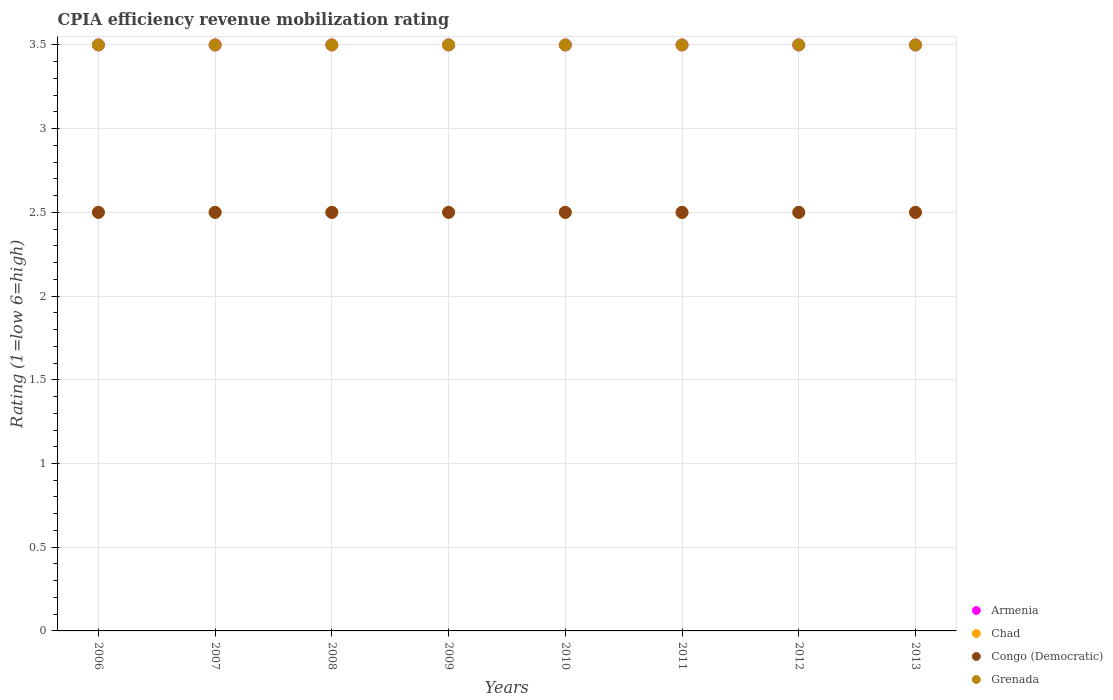Across all years, what is the maximum CPIA rating in Congo (Democratic)?
Your answer should be compact. 2.5. What is the total CPIA rating in Armenia in the graph?
Make the answer very short. 28. What is the difference between the CPIA rating in Chad in 2009 and that in 2013?
Your answer should be compact. 0. What is the average CPIA rating in Congo (Democratic) per year?
Your response must be concise. 2.5. In the year 2010, what is the difference between the CPIA rating in Armenia and CPIA rating in Chad?
Provide a succinct answer. 1. Is the CPIA rating in Chad in 2011 less than that in 2012?
Give a very brief answer. No. What is the difference between the highest and the lowest CPIA rating in Congo (Democratic)?
Make the answer very short. 0. Is the sum of the CPIA rating in Chad in 2010 and 2013 greater than the maximum CPIA rating in Armenia across all years?
Keep it short and to the point. Yes. Is the CPIA rating in Armenia strictly greater than the CPIA rating in Grenada over the years?
Provide a short and direct response. No. Is the CPIA rating in Chad strictly less than the CPIA rating in Congo (Democratic) over the years?
Your answer should be very brief. No. How many dotlines are there?
Provide a short and direct response. 4. How many years are there in the graph?
Give a very brief answer. 8. Are the values on the major ticks of Y-axis written in scientific E-notation?
Provide a succinct answer. No. Does the graph contain grids?
Your answer should be compact. Yes. How many legend labels are there?
Your answer should be very brief. 4. How are the legend labels stacked?
Your answer should be compact. Vertical. What is the title of the graph?
Offer a very short reply. CPIA efficiency revenue mobilization rating. What is the label or title of the Y-axis?
Your answer should be very brief. Rating (1=low 6=high). What is the Rating (1=low 6=high) of Armenia in 2006?
Your answer should be very brief. 3.5. What is the Rating (1=low 6=high) in Congo (Democratic) in 2006?
Your answer should be compact. 2.5. What is the Rating (1=low 6=high) in Grenada in 2006?
Keep it short and to the point. 3.5. What is the Rating (1=low 6=high) of Armenia in 2007?
Make the answer very short. 3.5. What is the Rating (1=low 6=high) in Chad in 2007?
Give a very brief answer. 2.5. What is the Rating (1=low 6=high) of Congo (Democratic) in 2007?
Give a very brief answer. 2.5. What is the Rating (1=low 6=high) in Grenada in 2007?
Your response must be concise. 3.5. What is the Rating (1=low 6=high) of Armenia in 2008?
Provide a succinct answer. 3.5. What is the Rating (1=low 6=high) of Chad in 2008?
Your answer should be compact. 2.5. What is the Rating (1=low 6=high) of Grenada in 2008?
Give a very brief answer. 3.5. What is the Rating (1=low 6=high) in Chad in 2009?
Your answer should be very brief. 2.5. What is the Rating (1=low 6=high) in Grenada in 2009?
Keep it short and to the point. 3.5. What is the Rating (1=low 6=high) in Armenia in 2010?
Offer a terse response. 3.5. What is the Rating (1=low 6=high) of Chad in 2010?
Offer a terse response. 2.5. What is the Rating (1=low 6=high) of Congo (Democratic) in 2010?
Your response must be concise. 2.5. What is the Rating (1=low 6=high) in Grenada in 2010?
Provide a succinct answer. 3.5. What is the Rating (1=low 6=high) in Armenia in 2011?
Ensure brevity in your answer.  3.5. What is the Rating (1=low 6=high) in Chad in 2011?
Ensure brevity in your answer.  2.5. What is the Rating (1=low 6=high) in Congo (Democratic) in 2011?
Your response must be concise. 2.5. What is the Rating (1=low 6=high) in Armenia in 2012?
Your answer should be very brief. 3.5. What is the Rating (1=low 6=high) in Congo (Democratic) in 2012?
Your answer should be very brief. 2.5. What is the Rating (1=low 6=high) of Grenada in 2012?
Make the answer very short. 3.5. What is the Rating (1=low 6=high) of Grenada in 2013?
Your answer should be compact. 3.5. Across all years, what is the maximum Rating (1=low 6=high) in Congo (Democratic)?
Give a very brief answer. 2.5. Across all years, what is the minimum Rating (1=low 6=high) in Congo (Democratic)?
Give a very brief answer. 2.5. Across all years, what is the minimum Rating (1=low 6=high) of Grenada?
Give a very brief answer. 3.5. What is the total Rating (1=low 6=high) of Chad in the graph?
Your answer should be very brief. 20. What is the total Rating (1=low 6=high) of Congo (Democratic) in the graph?
Ensure brevity in your answer.  20. What is the difference between the Rating (1=low 6=high) in Armenia in 2006 and that in 2007?
Give a very brief answer. 0. What is the difference between the Rating (1=low 6=high) in Chad in 2006 and that in 2007?
Offer a terse response. 0. What is the difference between the Rating (1=low 6=high) of Grenada in 2006 and that in 2007?
Ensure brevity in your answer.  0. What is the difference between the Rating (1=low 6=high) of Armenia in 2006 and that in 2008?
Offer a very short reply. 0. What is the difference between the Rating (1=low 6=high) of Congo (Democratic) in 2006 and that in 2008?
Make the answer very short. 0. What is the difference between the Rating (1=low 6=high) of Grenada in 2006 and that in 2008?
Offer a very short reply. 0. What is the difference between the Rating (1=low 6=high) in Chad in 2006 and that in 2009?
Offer a very short reply. 0. What is the difference between the Rating (1=low 6=high) in Chad in 2006 and that in 2010?
Your answer should be compact. 0. What is the difference between the Rating (1=low 6=high) in Congo (Democratic) in 2006 and that in 2010?
Your answer should be very brief. 0. What is the difference between the Rating (1=low 6=high) in Armenia in 2006 and that in 2011?
Provide a short and direct response. 0. What is the difference between the Rating (1=low 6=high) in Armenia in 2006 and that in 2012?
Your answer should be very brief. 0. What is the difference between the Rating (1=low 6=high) in Chad in 2006 and that in 2012?
Your answer should be compact. 0. What is the difference between the Rating (1=low 6=high) of Congo (Democratic) in 2006 and that in 2012?
Provide a short and direct response. 0. What is the difference between the Rating (1=low 6=high) in Grenada in 2006 and that in 2012?
Provide a succinct answer. 0. What is the difference between the Rating (1=low 6=high) in Armenia in 2006 and that in 2013?
Your response must be concise. 0. What is the difference between the Rating (1=low 6=high) in Chad in 2006 and that in 2013?
Keep it short and to the point. 0. What is the difference between the Rating (1=low 6=high) in Congo (Democratic) in 2006 and that in 2013?
Provide a short and direct response. 0. What is the difference between the Rating (1=low 6=high) in Armenia in 2007 and that in 2008?
Your response must be concise. 0. What is the difference between the Rating (1=low 6=high) of Chad in 2007 and that in 2008?
Offer a very short reply. 0. What is the difference between the Rating (1=low 6=high) of Grenada in 2007 and that in 2008?
Keep it short and to the point. 0. What is the difference between the Rating (1=low 6=high) of Armenia in 2007 and that in 2009?
Your answer should be compact. 0. What is the difference between the Rating (1=low 6=high) in Chad in 2007 and that in 2009?
Make the answer very short. 0. What is the difference between the Rating (1=low 6=high) in Congo (Democratic) in 2007 and that in 2009?
Offer a very short reply. 0. What is the difference between the Rating (1=low 6=high) of Grenada in 2007 and that in 2009?
Your response must be concise. 0. What is the difference between the Rating (1=low 6=high) of Chad in 2007 and that in 2010?
Ensure brevity in your answer.  0. What is the difference between the Rating (1=low 6=high) in Chad in 2007 and that in 2011?
Your answer should be compact. 0. What is the difference between the Rating (1=low 6=high) of Grenada in 2007 and that in 2011?
Your response must be concise. 0. What is the difference between the Rating (1=low 6=high) of Armenia in 2007 and that in 2012?
Your answer should be very brief. 0. What is the difference between the Rating (1=low 6=high) in Congo (Democratic) in 2007 and that in 2012?
Keep it short and to the point. 0. What is the difference between the Rating (1=low 6=high) of Grenada in 2007 and that in 2012?
Make the answer very short. 0. What is the difference between the Rating (1=low 6=high) of Armenia in 2007 and that in 2013?
Provide a short and direct response. 0. What is the difference between the Rating (1=low 6=high) of Congo (Democratic) in 2007 and that in 2013?
Offer a terse response. 0. What is the difference between the Rating (1=low 6=high) of Grenada in 2007 and that in 2013?
Offer a terse response. 0. What is the difference between the Rating (1=low 6=high) in Armenia in 2008 and that in 2010?
Your response must be concise. 0. What is the difference between the Rating (1=low 6=high) in Congo (Democratic) in 2008 and that in 2010?
Your answer should be very brief. 0. What is the difference between the Rating (1=low 6=high) of Grenada in 2008 and that in 2010?
Your answer should be compact. 0. What is the difference between the Rating (1=low 6=high) of Armenia in 2008 and that in 2011?
Keep it short and to the point. 0. What is the difference between the Rating (1=low 6=high) of Grenada in 2008 and that in 2011?
Your response must be concise. 0. What is the difference between the Rating (1=low 6=high) in Congo (Democratic) in 2008 and that in 2012?
Offer a terse response. 0. What is the difference between the Rating (1=low 6=high) of Armenia in 2008 and that in 2013?
Your response must be concise. 0. What is the difference between the Rating (1=low 6=high) in Chad in 2008 and that in 2013?
Ensure brevity in your answer.  0. What is the difference between the Rating (1=low 6=high) of Grenada in 2008 and that in 2013?
Your answer should be compact. 0. What is the difference between the Rating (1=low 6=high) of Grenada in 2009 and that in 2010?
Your answer should be compact. 0. What is the difference between the Rating (1=low 6=high) in Armenia in 2009 and that in 2011?
Make the answer very short. 0. What is the difference between the Rating (1=low 6=high) of Congo (Democratic) in 2009 and that in 2011?
Ensure brevity in your answer.  0. What is the difference between the Rating (1=low 6=high) of Chad in 2009 and that in 2012?
Provide a succinct answer. 0. What is the difference between the Rating (1=low 6=high) of Grenada in 2009 and that in 2012?
Offer a terse response. 0. What is the difference between the Rating (1=low 6=high) of Chad in 2009 and that in 2013?
Keep it short and to the point. 0. What is the difference between the Rating (1=low 6=high) in Congo (Democratic) in 2009 and that in 2013?
Give a very brief answer. 0. What is the difference between the Rating (1=low 6=high) of Armenia in 2010 and that in 2011?
Give a very brief answer. 0. What is the difference between the Rating (1=low 6=high) of Armenia in 2010 and that in 2012?
Provide a short and direct response. 0. What is the difference between the Rating (1=low 6=high) of Congo (Democratic) in 2010 and that in 2012?
Give a very brief answer. 0. What is the difference between the Rating (1=low 6=high) of Grenada in 2010 and that in 2012?
Provide a short and direct response. 0. What is the difference between the Rating (1=low 6=high) in Armenia in 2010 and that in 2013?
Provide a succinct answer. 0. What is the difference between the Rating (1=low 6=high) of Chad in 2010 and that in 2013?
Offer a terse response. 0. What is the difference between the Rating (1=low 6=high) of Congo (Democratic) in 2011 and that in 2012?
Provide a short and direct response. 0. What is the difference between the Rating (1=low 6=high) in Armenia in 2011 and that in 2013?
Offer a very short reply. 0. What is the difference between the Rating (1=low 6=high) of Grenada in 2011 and that in 2013?
Your answer should be compact. 0. What is the difference between the Rating (1=low 6=high) of Chad in 2012 and that in 2013?
Make the answer very short. 0. What is the difference between the Rating (1=low 6=high) in Grenada in 2012 and that in 2013?
Provide a short and direct response. 0. What is the difference between the Rating (1=low 6=high) in Armenia in 2006 and the Rating (1=low 6=high) in Congo (Democratic) in 2007?
Give a very brief answer. 1. What is the difference between the Rating (1=low 6=high) in Armenia in 2006 and the Rating (1=low 6=high) in Grenada in 2007?
Your response must be concise. 0. What is the difference between the Rating (1=low 6=high) in Chad in 2006 and the Rating (1=low 6=high) in Congo (Democratic) in 2007?
Offer a terse response. 0. What is the difference between the Rating (1=low 6=high) of Chad in 2006 and the Rating (1=low 6=high) of Grenada in 2007?
Your answer should be very brief. -1. What is the difference between the Rating (1=low 6=high) of Armenia in 2006 and the Rating (1=low 6=high) of Chad in 2008?
Keep it short and to the point. 1. What is the difference between the Rating (1=low 6=high) in Armenia in 2006 and the Rating (1=low 6=high) in Congo (Democratic) in 2008?
Ensure brevity in your answer.  1. What is the difference between the Rating (1=low 6=high) of Chad in 2006 and the Rating (1=low 6=high) of Congo (Democratic) in 2008?
Provide a succinct answer. 0. What is the difference between the Rating (1=low 6=high) in Congo (Democratic) in 2006 and the Rating (1=low 6=high) in Grenada in 2008?
Make the answer very short. -1. What is the difference between the Rating (1=low 6=high) of Armenia in 2006 and the Rating (1=low 6=high) of Grenada in 2009?
Your response must be concise. 0. What is the difference between the Rating (1=low 6=high) in Chad in 2006 and the Rating (1=low 6=high) in Congo (Democratic) in 2009?
Provide a succinct answer. 0. What is the difference between the Rating (1=low 6=high) of Chad in 2006 and the Rating (1=low 6=high) of Grenada in 2009?
Ensure brevity in your answer.  -1. What is the difference between the Rating (1=low 6=high) in Congo (Democratic) in 2006 and the Rating (1=low 6=high) in Grenada in 2009?
Keep it short and to the point. -1. What is the difference between the Rating (1=low 6=high) of Armenia in 2006 and the Rating (1=low 6=high) of Chad in 2010?
Your answer should be compact. 1. What is the difference between the Rating (1=low 6=high) of Armenia in 2006 and the Rating (1=low 6=high) of Grenada in 2010?
Your answer should be compact. 0. What is the difference between the Rating (1=low 6=high) in Chad in 2006 and the Rating (1=low 6=high) in Grenada in 2010?
Your response must be concise. -1. What is the difference between the Rating (1=low 6=high) of Congo (Democratic) in 2006 and the Rating (1=low 6=high) of Grenada in 2010?
Your response must be concise. -1. What is the difference between the Rating (1=low 6=high) of Armenia in 2006 and the Rating (1=low 6=high) of Grenada in 2011?
Your answer should be compact. 0. What is the difference between the Rating (1=low 6=high) of Armenia in 2006 and the Rating (1=low 6=high) of Chad in 2012?
Keep it short and to the point. 1. What is the difference between the Rating (1=low 6=high) in Armenia in 2006 and the Rating (1=low 6=high) in Congo (Democratic) in 2012?
Provide a succinct answer. 1. What is the difference between the Rating (1=low 6=high) of Chad in 2006 and the Rating (1=low 6=high) of Congo (Democratic) in 2012?
Keep it short and to the point. 0. What is the difference between the Rating (1=low 6=high) of Congo (Democratic) in 2006 and the Rating (1=low 6=high) of Grenada in 2012?
Provide a short and direct response. -1. What is the difference between the Rating (1=low 6=high) in Armenia in 2006 and the Rating (1=low 6=high) in Chad in 2013?
Make the answer very short. 1. What is the difference between the Rating (1=low 6=high) of Chad in 2006 and the Rating (1=low 6=high) of Congo (Democratic) in 2013?
Keep it short and to the point. 0. What is the difference between the Rating (1=low 6=high) of Chad in 2006 and the Rating (1=low 6=high) of Grenada in 2013?
Provide a succinct answer. -1. What is the difference between the Rating (1=low 6=high) in Congo (Democratic) in 2006 and the Rating (1=low 6=high) in Grenada in 2013?
Your answer should be compact. -1. What is the difference between the Rating (1=low 6=high) of Armenia in 2007 and the Rating (1=low 6=high) of Chad in 2008?
Offer a very short reply. 1. What is the difference between the Rating (1=low 6=high) of Armenia in 2007 and the Rating (1=low 6=high) of Grenada in 2008?
Your response must be concise. 0. What is the difference between the Rating (1=low 6=high) in Chad in 2007 and the Rating (1=low 6=high) in Congo (Democratic) in 2008?
Offer a terse response. 0. What is the difference between the Rating (1=low 6=high) in Congo (Democratic) in 2007 and the Rating (1=low 6=high) in Grenada in 2008?
Give a very brief answer. -1. What is the difference between the Rating (1=low 6=high) in Armenia in 2007 and the Rating (1=low 6=high) in Chad in 2009?
Provide a short and direct response. 1. What is the difference between the Rating (1=low 6=high) of Armenia in 2007 and the Rating (1=low 6=high) of Congo (Democratic) in 2009?
Offer a very short reply. 1. What is the difference between the Rating (1=low 6=high) of Armenia in 2007 and the Rating (1=low 6=high) of Grenada in 2009?
Offer a terse response. 0. What is the difference between the Rating (1=low 6=high) in Chad in 2007 and the Rating (1=low 6=high) in Congo (Democratic) in 2009?
Keep it short and to the point. 0. What is the difference between the Rating (1=low 6=high) in Congo (Democratic) in 2007 and the Rating (1=low 6=high) in Grenada in 2009?
Provide a short and direct response. -1. What is the difference between the Rating (1=low 6=high) of Chad in 2007 and the Rating (1=low 6=high) of Congo (Democratic) in 2010?
Make the answer very short. 0. What is the difference between the Rating (1=low 6=high) of Chad in 2007 and the Rating (1=low 6=high) of Grenada in 2010?
Your answer should be compact. -1. What is the difference between the Rating (1=low 6=high) of Armenia in 2007 and the Rating (1=low 6=high) of Congo (Democratic) in 2011?
Provide a short and direct response. 1. What is the difference between the Rating (1=low 6=high) of Chad in 2007 and the Rating (1=low 6=high) of Grenada in 2011?
Offer a terse response. -1. What is the difference between the Rating (1=low 6=high) of Congo (Democratic) in 2007 and the Rating (1=low 6=high) of Grenada in 2011?
Ensure brevity in your answer.  -1. What is the difference between the Rating (1=low 6=high) of Armenia in 2007 and the Rating (1=low 6=high) of Congo (Democratic) in 2012?
Your answer should be compact. 1. What is the difference between the Rating (1=low 6=high) of Armenia in 2007 and the Rating (1=low 6=high) of Grenada in 2012?
Offer a very short reply. 0. What is the difference between the Rating (1=low 6=high) in Chad in 2007 and the Rating (1=low 6=high) in Congo (Democratic) in 2012?
Offer a very short reply. 0. What is the difference between the Rating (1=low 6=high) of Chad in 2007 and the Rating (1=low 6=high) of Grenada in 2012?
Provide a short and direct response. -1. What is the difference between the Rating (1=low 6=high) in Armenia in 2007 and the Rating (1=low 6=high) in Chad in 2013?
Your response must be concise. 1. What is the difference between the Rating (1=low 6=high) in Armenia in 2007 and the Rating (1=low 6=high) in Congo (Democratic) in 2013?
Offer a terse response. 1. What is the difference between the Rating (1=low 6=high) of Armenia in 2007 and the Rating (1=low 6=high) of Grenada in 2013?
Your response must be concise. 0. What is the difference between the Rating (1=low 6=high) of Chad in 2007 and the Rating (1=low 6=high) of Congo (Democratic) in 2013?
Make the answer very short. 0. What is the difference between the Rating (1=low 6=high) of Congo (Democratic) in 2007 and the Rating (1=low 6=high) of Grenada in 2013?
Offer a very short reply. -1. What is the difference between the Rating (1=low 6=high) in Armenia in 2008 and the Rating (1=low 6=high) in Chad in 2009?
Provide a short and direct response. 1. What is the difference between the Rating (1=low 6=high) in Chad in 2008 and the Rating (1=low 6=high) in Grenada in 2009?
Offer a terse response. -1. What is the difference between the Rating (1=low 6=high) of Armenia in 2008 and the Rating (1=low 6=high) of Congo (Democratic) in 2010?
Your response must be concise. 1. What is the difference between the Rating (1=low 6=high) in Armenia in 2008 and the Rating (1=low 6=high) in Grenada in 2010?
Ensure brevity in your answer.  0. What is the difference between the Rating (1=low 6=high) in Chad in 2008 and the Rating (1=low 6=high) in Congo (Democratic) in 2010?
Provide a short and direct response. 0. What is the difference between the Rating (1=low 6=high) of Armenia in 2008 and the Rating (1=low 6=high) of Grenada in 2011?
Ensure brevity in your answer.  0. What is the difference between the Rating (1=low 6=high) in Armenia in 2008 and the Rating (1=low 6=high) in Chad in 2012?
Ensure brevity in your answer.  1. What is the difference between the Rating (1=low 6=high) in Armenia in 2008 and the Rating (1=low 6=high) in Congo (Democratic) in 2012?
Provide a short and direct response. 1. What is the difference between the Rating (1=low 6=high) in Armenia in 2008 and the Rating (1=low 6=high) in Grenada in 2012?
Provide a succinct answer. 0. What is the difference between the Rating (1=low 6=high) of Congo (Democratic) in 2008 and the Rating (1=low 6=high) of Grenada in 2012?
Make the answer very short. -1. What is the difference between the Rating (1=low 6=high) of Armenia in 2008 and the Rating (1=low 6=high) of Chad in 2013?
Ensure brevity in your answer.  1. What is the difference between the Rating (1=low 6=high) in Chad in 2008 and the Rating (1=low 6=high) in Congo (Democratic) in 2013?
Your answer should be very brief. 0. What is the difference between the Rating (1=low 6=high) in Congo (Democratic) in 2008 and the Rating (1=low 6=high) in Grenada in 2013?
Provide a short and direct response. -1. What is the difference between the Rating (1=low 6=high) of Chad in 2009 and the Rating (1=low 6=high) of Congo (Democratic) in 2010?
Ensure brevity in your answer.  0. What is the difference between the Rating (1=low 6=high) of Armenia in 2009 and the Rating (1=low 6=high) of Chad in 2011?
Give a very brief answer. 1. What is the difference between the Rating (1=low 6=high) in Armenia in 2009 and the Rating (1=low 6=high) in Congo (Democratic) in 2011?
Ensure brevity in your answer.  1. What is the difference between the Rating (1=low 6=high) in Armenia in 2009 and the Rating (1=low 6=high) in Grenada in 2011?
Offer a very short reply. 0. What is the difference between the Rating (1=low 6=high) in Chad in 2009 and the Rating (1=low 6=high) in Grenada in 2011?
Give a very brief answer. -1. What is the difference between the Rating (1=low 6=high) of Armenia in 2009 and the Rating (1=low 6=high) of Chad in 2012?
Provide a short and direct response. 1. What is the difference between the Rating (1=low 6=high) in Armenia in 2009 and the Rating (1=low 6=high) in Congo (Democratic) in 2012?
Make the answer very short. 1. What is the difference between the Rating (1=low 6=high) in Chad in 2009 and the Rating (1=low 6=high) in Congo (Democratic) in 2012?
Keep it short and to the point. 0. What is the difference between the Rating (1=low 6=high) of Armenia in 2009 and the Rating (1=low 6=high) of Chad in 2013?
Ensure brevity in your answer.  1. What is the difference between the Rating (1=low 6=high) in Armenia in 2009 and the Rating (1=low 6=high) in Grenada in 2013?
Keep it short and to the point. 0. What is the difference between the Rating (1=low 6=high) in Armenia in 2010 and the Rating (1=low 6=high) in Chad in 2011?
Offer a very short reply. 1. What is the difference between the Rating (1=low 6=high) in Armenia in 2010 and the Rating (1=low 6=high) in Congo (Democratic) in 2011?
Offer a terse response. 1. What is the difference between the Rating (1=low 6=high) of Armenia in 2010 and the Rating (1=low 6=high) of Grenada in 2011?
Your answer should be compact. 0. What is the difference between the Rating (1=low 6=high) in Chad in 2010 and the Rating (1=low 6=high) in Congo (Democratic) in 2011?
Your answer should be compact. 0. What is the difference between the Rating (1=low 6=high) in Armenia in 2010 and the Rating (1=low 6=high) in Congo (Democratic) in 2012?
Provide a succinct answer. 1. What is the difference between the Rating (1=low 6=high) in Armenia in 2010 and the Rating (1=low 6=high) in Grenada in 2012?
Make the answer very short. 0. What is the difference between the Rating (1=low 6=high) of Chad in 2010 and the Rating (1=low 6=high) of Congo (Democratic) in 2012?
Your response must be concise. 0. What is the difference between the Rating (1=low 6=high) in Chad in 2010 and the Rating (1=low 6=high) in Grenada in 2012?
Provide a succinct answer. -1. What is the difference between the Rating (1=low 6=high) of Armenia in 2010 and the Rating (1=low 6=high) of Chad in 2013?
Offer a very short reply. 1. What is the difference between the Rating (1=low 6=high) in Chad in 2010 and the Rating (1=low 6=high) in Grenada in 2013?
Keep it short and to the point. -1. What is the difference between the Rating (1=low 6=high) in Congo (Democratic) in 2010 and the Rating (1=low 6=high) in Grenada in 2013?
Offer a very short reply. -1. What is the difference between the Rating (1=low 6=high) in Chad in 2011 and the Rating (1=low 6=high) in Congo (Democratic) in 2012?
Give a very brief answer. 0. What is the difference between the Rating (1=low 6=high) in Chad in 2011 and the Rating (1=low 6=high) in Grenada in 2012?
Provide a short and direct response. -1. What is the difference between the Rating (1=low 6=high) of Congo (Democratic) in 2011 and the Rating (1=low 6=high) of Grenada in 2012?
Keep it short and to the point. -1. What is the difference between the Rating (1=low 6=high) of Chad in 2011 and the Rating (1=low 6=high) of Grenada in 2013?
Provide a succinct answer. -1. What is the difference between the Rating (1=low 6=high) in Armenia in 2012 and the Rating (1=low 6=high) in Congo (Democratic) in 2013?
Give a very brief answer. 1. What is the difference between the Rating (1=low 6=high) of Armenia in 2012 and the Rating (1=low 6=high) of Grenada in 2013?
Your answer should be very brief. 0. What is the difference between the Rating (1=low 6=high) in Chad in 2012 and the Rating (1=low 6=high) in Congo (Democratic) in 2013?
Your response must be concise. 0. What is the difference between the Rating (1=low 6=high) of Chad in 2012 and the Rating (1=low 6=high) of Grenada in 2013?
Provide a succinct answer. -1. What is the difference between the Rating (1=low 6=high) of Congo (Democratic) in 2012 and the Rating (1=low 6=high) of Grenada in 2013?
Provide a short and direct response. -1. What is the average Rating (1=low 6=high) in Congo (Democratic) per year?
Give a very brief answer. 2.5. What is the average Rating (1=low 6=high) in Grenada per year?
Make the answer very short. 3.5. In the year 2006, what is the difference between the Rating (1=low 6=high) in Armenia and Rating (1=low 6=high) in Chad?
Your answer should be compact. 1. In the year 2006, what is the difference between the Rating (1=low 6=high) in Armenia and Rating (1=low 6=high) in Congo (Democratic)?
Your answer should be compact. 1. In the year 2006, what is the difference between the Rating (1=low 6=high) of Armenia and Rating (1=low 6=high) of Grenada?
Ensure brevity in your answer.  0. In the year 2006, what is the difference between the Rating (1=low 6=high) in Congo (Democratic) and Rating (1=low 6=high) in Grenada?
Keep it short and to the point. -1. In the year 2007, what is the difference between the Rating (1=low 6=high) of Armenia and Rating (1=low 6=high) of Congo (Democratic)?
Provide a short and direct response. 1. In the year 2007, what is the difference between the Rating (1=low 6=high) of Chad and Rating (1=low 6=high) of Congo (Democratic)?
Make the answer very short. 0. In the year 2007, what is the difference between the Rating (1=low 6=high) of Chad and Rating (1=low 6=high) of Grenada?
Your answer should be compact. -1. In the year 2008, what is the difference between the Rating (1=low 6=high) of Armenia and Rating (1=low 6=high) of Chad?
Provide a short and direct response. 1. In the year 2009, what is the difference between the Rating (1=low 6=high) of Armenia and Rating (1=low 6=high) of Chad?
Keep it short and to the point. 1. In the year 2009, what is the difference between the Rating (1=low 6=high) in Armenia and Rating (1=low 6=high) in Grenada?
Your response must be concise. 0. In the year 2009, what is the difference between the Rating (1=low 6=high) in Chad and Rating (1=low 6=high) in Congo (Democratic)?
Offer a very short reply. 0. In the year 2009, what is the difference between the Rating (1=low 6=high) in Chad and Rating (1=low 6=high) in Grenada?
Give a very brief answer. -1. In the year 2010, what is the difference between the Rating (1=low 6=high) in Armenia and Rating (1=low 6=high) in Chad?
Offer a terse response. 1. In the year 2010, what is the difference between the Rating (1=low 6=high) in Armenia and Rating (1=low 6=high) in Congo (Democratic)?
Make the answer very short. 1. In the year 2010, what is the difference between the Rating (1=low 6=high) of Chad and Rating (1=low 6=high) of Grenada?
Provide a succinct answer. -1. In the year 2011, what is the difference between the Rating (1=low 6=high) in Armenia and Rating (1=low 6=high) in Chad?
Keep it short and to the point. 1. In the year 2011, what is the difference between the Rating (1=low 6=high) in Chad and Rating (1=low 6=high) in Congo (Democratic)?
Your response must be concise. 0. In the year 2011, what is the difference between the Rating (1=low 6=high) in Chad and Rating (1=low 6=high) in Grenada?
Offer a terse response. -1. In the year 2011, what is the difference between the Rating (1=low 6=high) in Congo (Democratic) and Rating (1=low 6=high) in Grenada?
Provide a short and direct response. -1. In the year 2012, what is the difference between the Rating (1=low 6=high) of Armenia and Rating (1=low 6=high) of Grenada?
Give a very brief answer. 0. In the year 2013, what is the difference between the Rating (1=low 6=high) of Armenia and Rating (1=low 6=high) of Grenada?
Offer a terse response. 0. In the year 2013, what is the difference between the Rating (1=low 6=high) in Chad and Rating (1=low 6=high) in Grenada?
Provide a succinct answer. -1. In the year 2013, what is the difference between the Rating (1=low 6=high) of Congo (Democratic) and Rating (1=low 6=high) of Grenada?
Your answer should be compact. -1. What is the ratio of the Rating (1=low 6=high) in Armenia in 2006 to that in 2007?
Provide a succinct answer. 1. What is the ratio of the Rating (1=low 6=high) of Chad in 2006 to that in 2007?
Your answer should be very brief. 1. What is the ratio of the Rating (1=low 6=high) of Grenada in 2006 to that in 2007?
Give a very brief answer. 1. What is the ratio of the Rating (1=low 6=high) of Armenia in 2006 to that in 2008?
Give a very brief answer. 1. What is the ratio of the Rating (1=low 6=high) of Congo (Democratic) in 2006 to that in 2008?
Give a very brief answer. 1. What is the ratio of the Rating (1=low 6=high) of Congo (Democratic) in 2006 to that in 2009?
Make the answer very short. 1. What is the ratio of the Rating (1=low 6=high) of Grenada in 2006 to that in 2009?
Your response must be concise. 1. What is the ratio of the Rating (1=low 6=high) in Armenia in 2006 to that in 2010?
Give a very brief answer. 1. What is the ratio of the Rating (1=low 6=high) of Chad in 2006 to that in 2011?
Provide a succinct answer. 1. What is the ratio of the Rating (1=low 6=high) in Grenada in 2006 to that in 2011?
Your answer should be compact. 1. What is the ratio of the Rating (1=low 6=high) in Armenia in 2006 to that in 2012?
Your response must be concise. 1. What is the ratio of the Rating (1=low 6=high) in Congo (Democratic) in 2006 to that in 2012?
Your answer should be very brief. 1. What is the ratio of the Rating (1=low 6=high) in Grenada in 2006 to that in 2012?
Your response must be concise. 1. What is the ratio of the Rating (1=low 6=high) in Armenia in 2006 to that in 2013?
Offer a terse response. 1. What is the ratio of the Rating (1=low 6=high) of Congo (Democratic) in 2006 to that in 2013?
Keep it short and to the point. 1. What is the ratio of the Rating (1=low 6=high) in Chad in 2007 to that in 2008?
Ensure brevity in your answer.  1. What is the ratio of the Rating (1=low 6=high) in Congo (Democratic) in 2007 to that in 2008?
Make the answer very short. 1. What is the ratio of the Rating (1=low 6=high) in Grenada in 2007 to that in 2008?
Provide a succinct answer. 1. What is the ratio of the Rating (1=low 6=high) in Armenia in 2007 to that in 2009?
Your response must be concise. 1. What is the ratio of the Rating (1=low 6=high) of Grenada in 2007 to that in 2009?
Make the answer very short. 1. What is the ratio of the Rating (1=low 6=high) of Armenia in 2007 to that in 2010?
Your answer should be very brief. 1. What is the ratio of the Rating (1=low 6=high) of Congo (Democratic) in 2007 to that in 2010?
Keep it short and to the point. 1. What is the ratio of the Rating (1=low 6=high) in Grenada in 2007 to that in 2010?
Offer a terse response. 1. What is the ratio of the Rating (1=low 6=high) of Chad in 2007 to that in 2011?
Offer a terse response. 1. What is the ratio of the Rating (1=low 6=high) of Grenada in 2007 to that in 2011?
Keep it short and to the point. 1. What is the ratio of the Rating (1=low 6=high) in Chad in 2007 to that in 2012?
Ensure brevity in your answer.  1. What is the ratio of the Rating (1=low 6=high) in Congo (Democratic) in 2007 to that in 2012?
Provide a short and direct response. 1. What is the ratio of the Rating (1=low 6=high) of Grenada in 2007 to that in 2012?
Give a very brief answer. 1. What is the ratio of the Rating (1=low 6=high) in Grenada in 2007 to that in 2013?
Offer a very short reply. 1. What is the ratio of the Rating (1=low 6=high) in Congo (Democratic) in 2008 to that in 2009?
Keep it short and to the point. 1. What is the ratio of the Rating (1=low 6=high) of Chad in 2008 to that in 2010?
Offer a very short reply. 1. What is the ratio of the Rating (1=low 6=high) of Grenada in 2008 to that in 2010?
Ensure brevity in your answer.  1. What is the ratio of the Rating (1=low 6=high) in Chad in 2008 to that in 2011?
Offer a very short reply. 1. What is the ratio of the Rating (1=low 6=high) in Congo (Democratic) in 2008 to that in 2011?
Offer a terse response. 1. What is the ratio of the Rating (1=low 6=high) of Grenada in 2008 to that in 2011?
Your response must be concise. 1. What is the ratio of the Rating (1=low 6=high) in Armenia in 2008 to that in 2012?
Offer a terse response. 1. What is the ratio of the Rating (1=low 6=high) in Chad in 2008 to that in 2012?
Provide a succinct answer. 1. What is the ratio of the Rating (1=low 6=high) of Armenia in 2008 to that in 2013?
Offer a very short reply. 1. What is the ratio of the Rating (1=low 6=high) of Chad in 2008 to that in 2013?
Make the answer very short. 1. What is the ratio of the Rating (1=low 6=high) of Grenada in 2008 to that in 2013?
Offer a terse response. 1. What is the ratio of the Rating (1=low 6=high) of Armenia in 2009 to that in 2010?
Ensure brevity in your answer.  1. What is the ratio of the Rating (1=low 6=high) of Chad in 2009 to that in 2010?
Ensure brevity in your answer.  1. What is the ratio of the Rating (1=low 6=high) of Chad in 2009 to that in 2011?
Provide a short and direct response. 1. What is the ratio of the Rating (1=low 6=high) in Congo (Democratic) in 2009 to that in 2011?
Your response must be concise. 1. What is the ratio of the Rating (1=low 6=high) of Chad in 2009 to that in 2012?
Provide a short and direct response. 1. What is the ratio of the Rating (1=low 6=high) of Grenada in 2009 to that in 2012?
Ensure brevity in your answer.  1. What is the ratio of the Rating (1=low 6=high) in Chad in 2009 to that in 2013?
Provide a succinct answer. 1. What is the ratio of the Rating (1=low 6=high) in Congo (Democratic) in 2009 to that in 2013?
Your answer should be compact. 1. What is the ratio of the Rating (1=low 6=high) in Grenada in 2009 to that in 2013?
Offer a terse response. 1. What is the ratio of the Rating (1=low 6=high) in Armenia in 2010 to that in 2012?
Provide a short and direct response. 1. What is the ratio of the Rating (1=low 6=high) in Chad in 2010 to that in 2012?
Your response must be concise. 1. What is the ratio of the Rating (1=low 6=high) of Congo (Democratic) in 2010 to that in 2012?
Keep it short and to the point. 1. What is the ratio of the Rating (1=low 6=high) of Armenia in 2010 to that in 2013?
Provide a short and direct response. 1. What is the ratio of the Rating (1=low 6=high) in Grenada in 2010 to that in 2013?
Offer a terse response. 1. What is the ratio of the Rating (1=low 6=high) of Armenia in 2011 to that in 2012?
Your answer should be compact. 1. What is the ratio of the Rating (1=low 6=high) of Grenada in 2011 to that in 2012?
Your answer should be very brief. 1. What is the ratio of the Rating (1=low 6=high) in Armenia in 2011 to that in 2013?
Provide a short and direct response. 1. What is the ratio of the Rating (1=low 6=high) of Chad in 2011 to that in 2013?
Your response must be concise. 1. What is the ratio of the Rating (1=low 6=high) of Grenada in 2011 to that in 2013?
Your answer should be very brief. 1. What is the ratio of the Rating (1=low 6=high) of Chad in 2012 to that in 2013?
Your answer should be very brief. 1. What is the difference between the highest and the second highest Rating (1=low 6=high) in Armenia?
Your response must be concise. 0. What is the difference between the highest and the second highest Rating (1=low 6=high) in Chad?
Your answer should be very brief. 0. What is the difference between the highest and the lowest Rating (1=low 6=high) in Armenia?
Your response must be concise. 0. What is the difference between the highest and the lowest Rating (1=low 6=high) in Grenada?
Give a very brief answer. 0. 